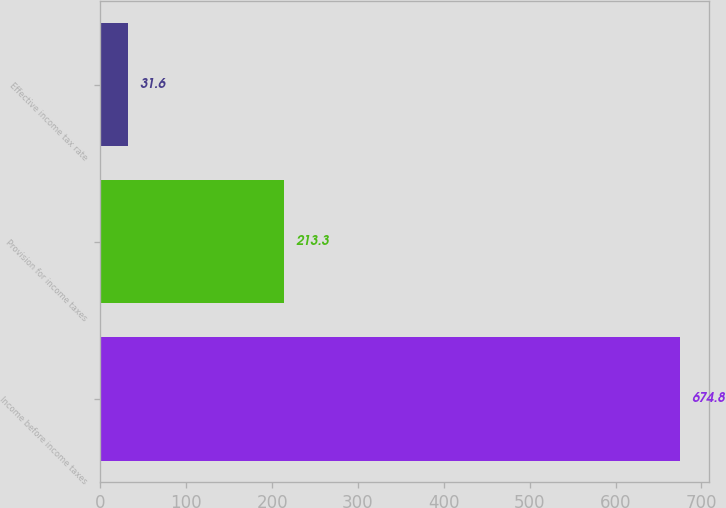<chart> <loc_0><loc_0><loc_500><loc_500><bar_chart><fcel>Income before income taxes<fcel>Provision for income taxes<fcel>Effective income tax rate<nl><fcel>674.8<fcel>213.3<fcel>31.6<nl></chart> 